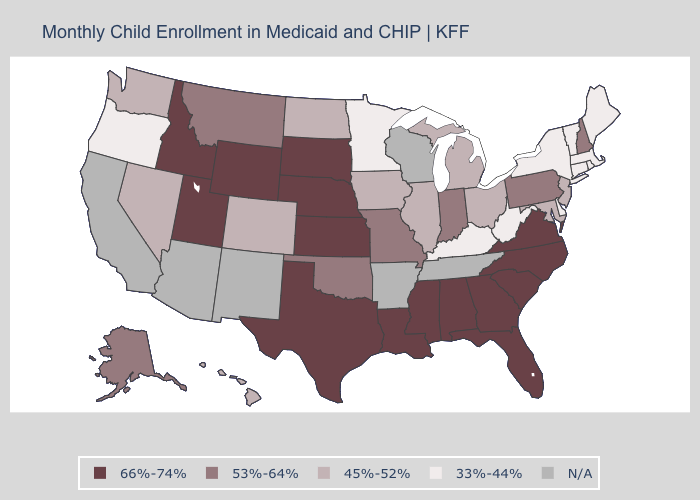Name the states that have a value in the range 53%-64%?
Answer briefly. Alaska, Indiana, Missouri, Montana, New Hampshire, Oklahoma, Pennsylvania. What is the value of Idaho?
Short answer required. 66%-74%. Does the first symbol in the legend represent the smallest category?
Answer briefly. No. Which states hav the highest value in the South?
Give a very brief answer. Alabama, Florida, Georgia, Louisiana, Mississippi, North Carolina, South Carolina, Texas, Virginia. Among the states that border Arizona , which have the lowest value?
Short answer required. Colorado, Nevada. What is the lowest value in the West?
Write a very short answer. 33%-44%. What is the value of Utah?
Be succinct. 66%-74%. Does New Hampshire have the highest value in the USA?
Answer briefly. No. Does the map have missing data?
Short answer required. Yes. Does Idaho have the highest value in the USA?
Quick response, please. Yes. What is the value of Tennessee?
Answer briefly. N/A. Does the map have missing data?
Short answer required. Yes. How many symbols are there in the legend?
Keep it brief. 5. 